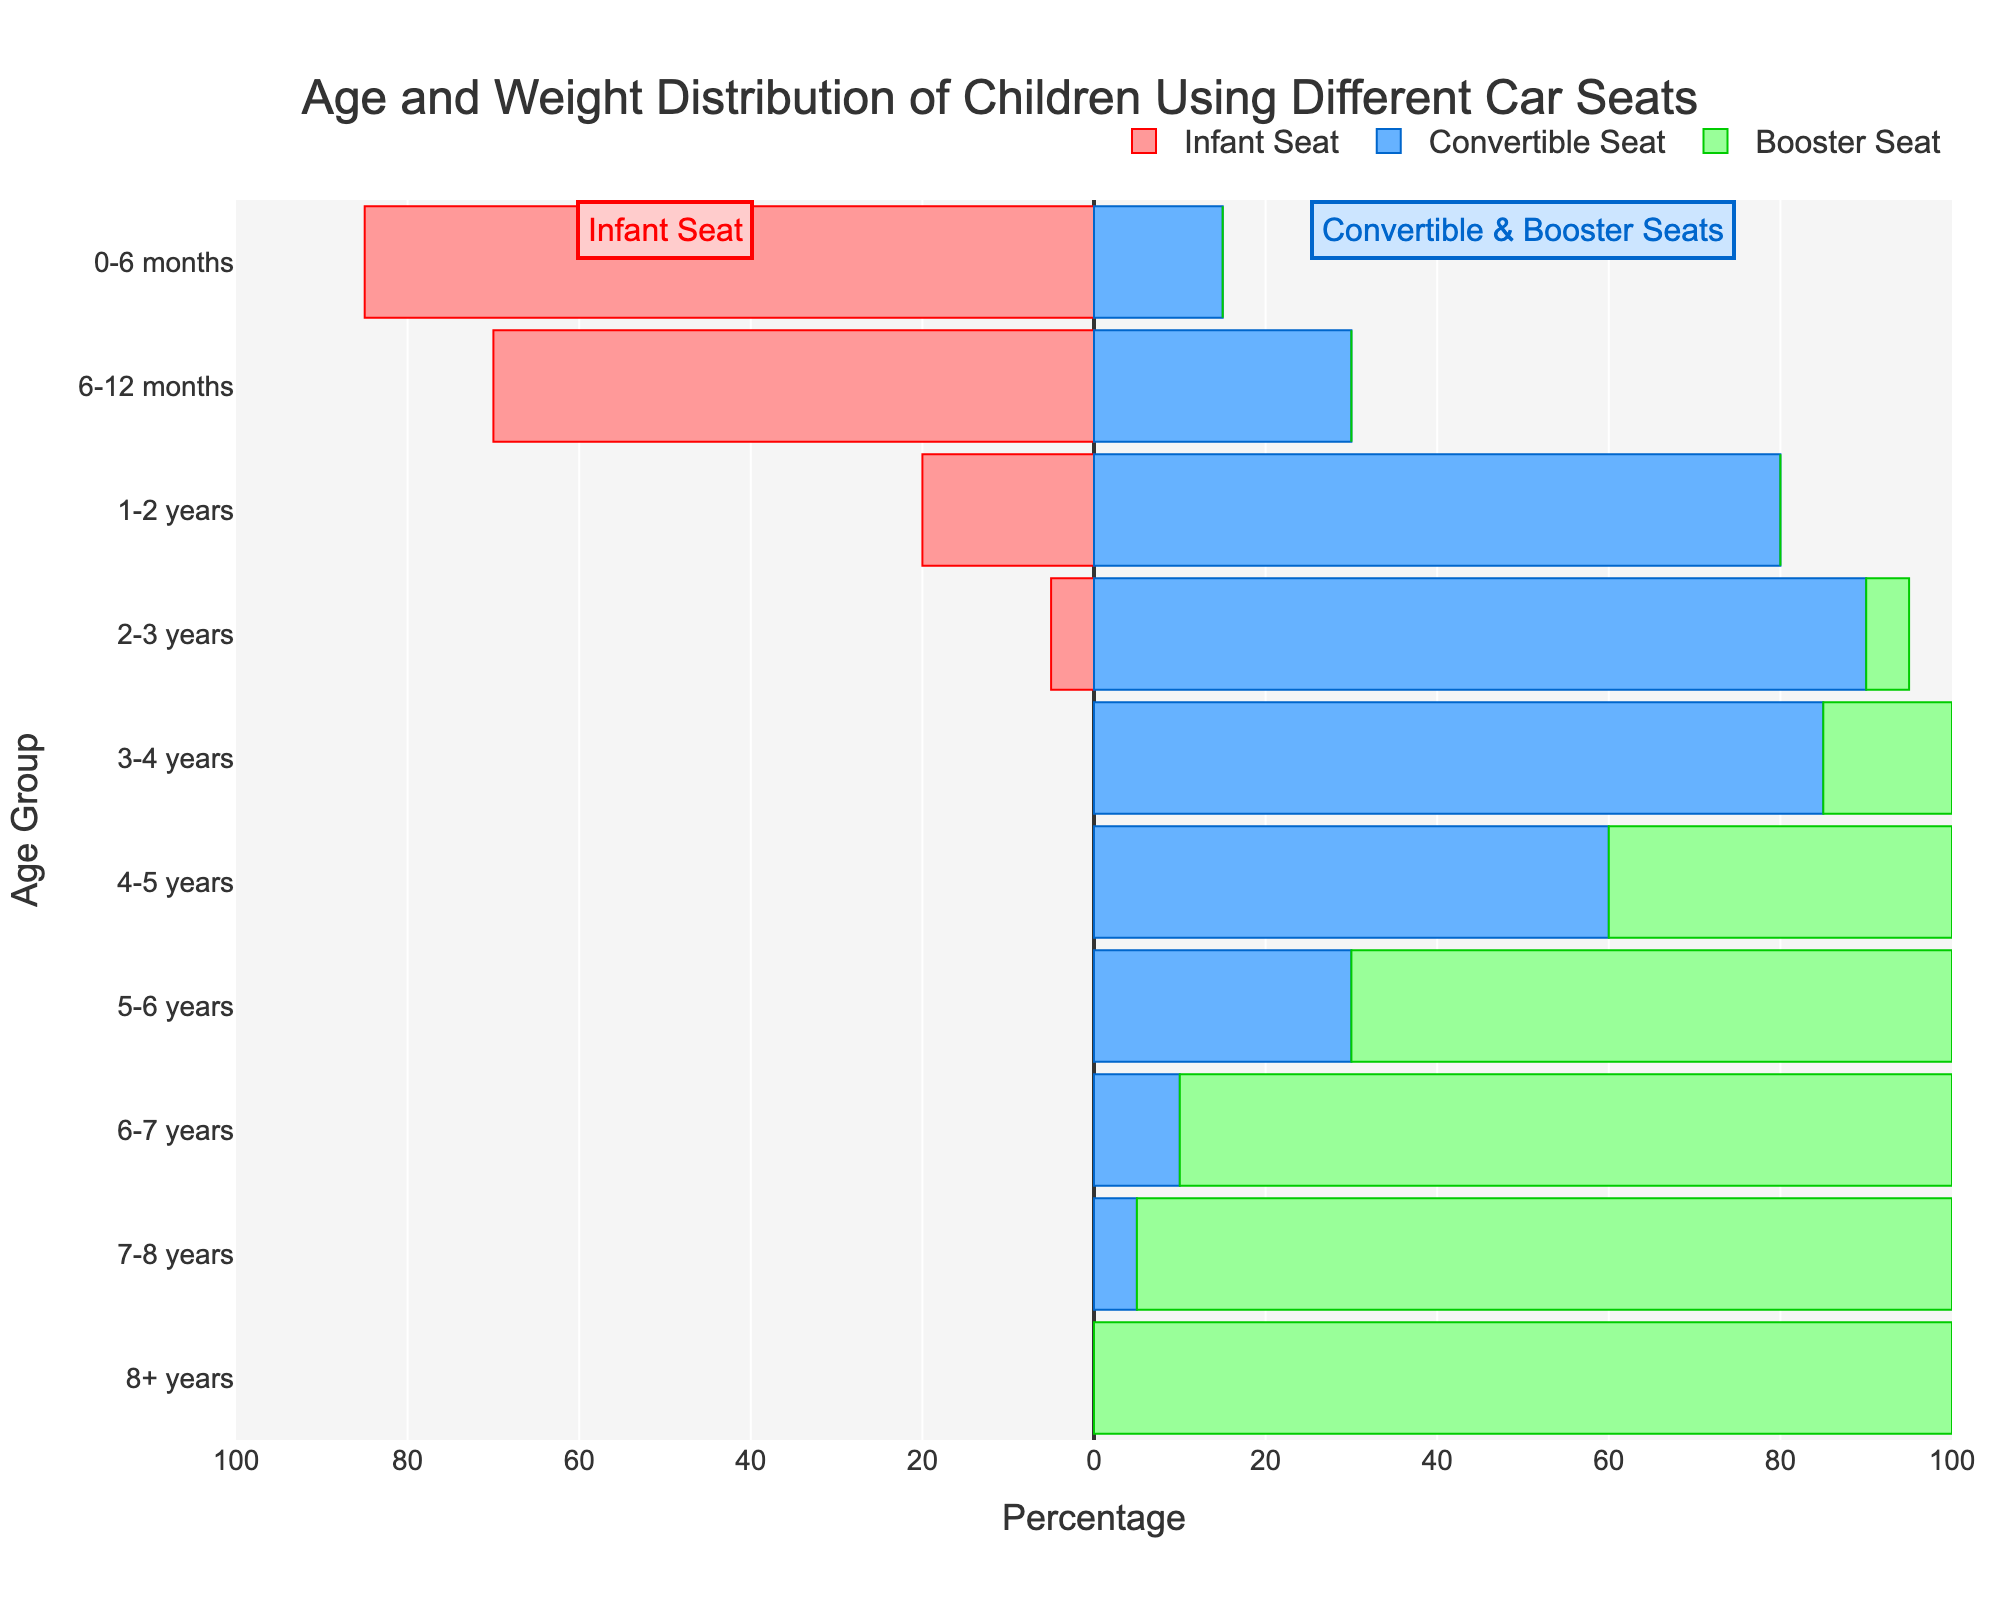What age group most commonly uses infant seats? Observing the left side of the population pyramid, the highest value for infant seats corresponds to the 0-6 months age group with 85%.
Answer: 0-6 months What is the percentage difference in the use of convertible seats between the 4-5 year and the 6-7 year age groups? From the figure, the use of convertible seats is 60% for 4-5 years and 10% for 6-7 years. The percentage difference is 60 - 10 = 50%.
Answer: 50% Which age group exclusively uses booster seats? Reviewing the population pyramid on the right side, only the 8+ years age group relies entirely on booster seats, with 100%.
Answer: 8+ years How does the use of car seats change from 3-4 years to 5-6 years? Between the 3-4 years and 5-6 years age groups, the use of convertible seats drops from 85% to 30%, while the use of booster seats increases from 15% to 70%.
Answer: Convertible seats decrease, booster seats increase What is the combined percentage for the use of convertible and booster seats for the 3-4 years age group? The figure shows that within the 3-4 years age group, the convertible seat usage is 85% and booster seat usage is 15%. Adding these gives a combined total of 85 + 15 = 100%.
Answer: 100% Which age group has the lowest usage of convertible seats? The figure shows the smallest value for convertible seats is 0% at the 8+ years age group.
Answer: 8+ years What percentage of 2-3 year olds use infant seats? Looking at the population pyramid, we see that only 5% of 2-3 year olds use infant seats.
Answer: 5% Is the use of car seats more spread out in younger or older children? The population pyramid shows a concentration of infant and convertible seat use in younger children and a spread distinction of booster seats as the age increases. So, the use is more concentrated in younger children and more spread out in older children.
Answer: Older children 